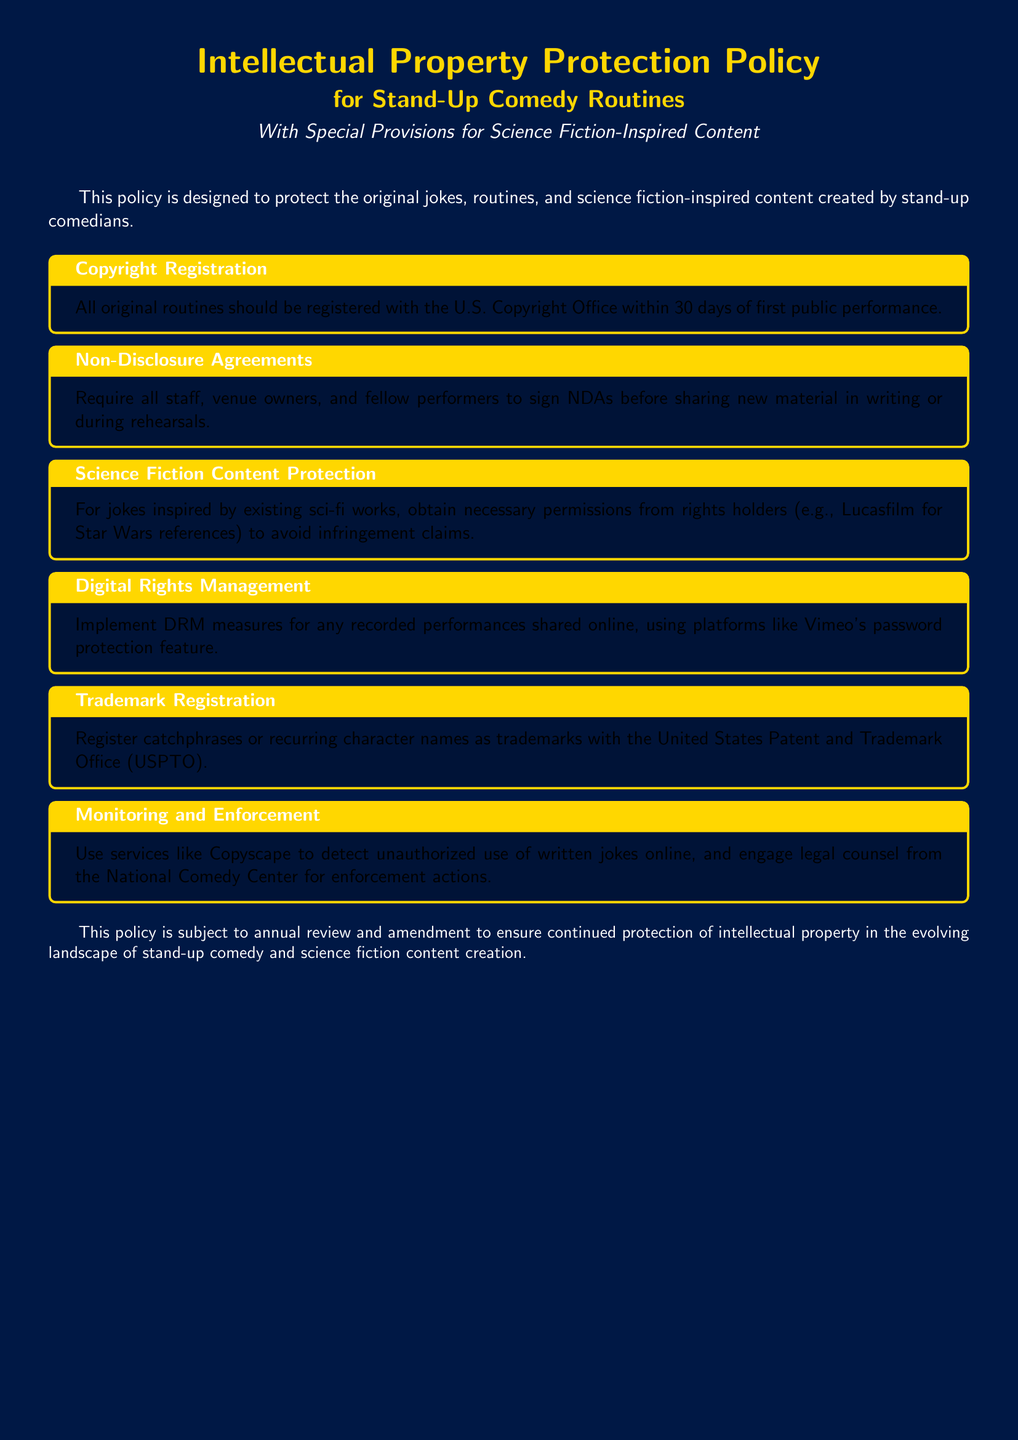What is the title of the policy? The title is presented at the beginning of the document, specifying its focus on intellectual property protection for stand-up comedy routines, with special provisions for science fiction-inspired content.
Answer: Intellectual Property Protection Policy for Stand-Up Comedy Routines How long do comedians have to register their original routines? The document specifies a timeframe for registration with the U.S. Copyright Office following the first public performance.
Answer: 30 days What must staff and venue owners sign before sharing new material? The document mandates an agreement that must be signed to protect shared content among those involved in performances.
Answer: NDAs What must comedians obtain for jokes inspired by existing science fiction works? The policy states that necessary permissions from rights holders are required for avoiding infringement claims.
Answer: Permissions Which office should trademarks be registered with? The document indicates the appropriate office for registering trademarks related to catchphrases or character names used in routines.
Answer: United States Patent and Trademark Office What tool should be used to detect unauthorized use of jokes online? The document suggests a service that helps in monitoring for unauthorized reproductions of material shared on the internet.
Answer: Copyscape How often is this policy subject to review? The document mentions a schedule for ongoing assessment of the policy to adapt to changes in the landscape of comedy and content creation.
Answer: Annually What is the color of the document background? The color scheme is specifically designed to align with a space-themed aesthetic throughout the document.
Answer: Space blue 